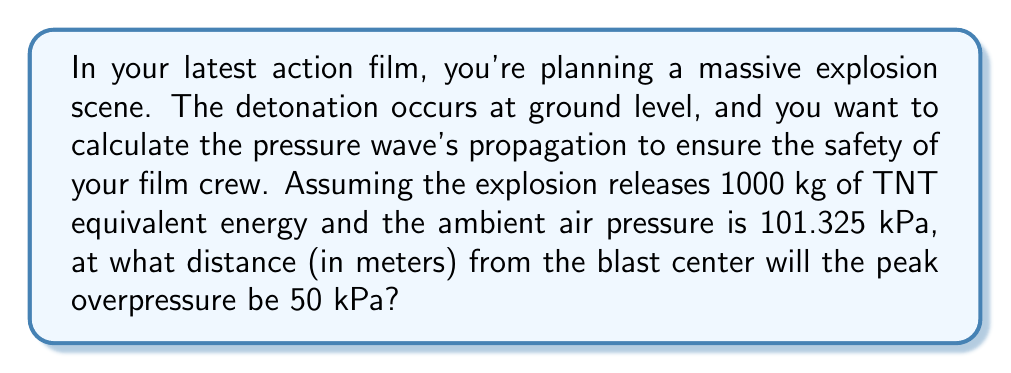Can you answer this question? To solve this problem, we'll use the Sadovsky formula for spherical blast waves. The steps are as follows:

1) The Sadovsky formula for peak overpressure $\Delta P$ (in kPa) is:

   $$\Delta P = \frac{0.084}{Z} + \frac{0.27}{Z^2} + \frac{0.7}{Z^3}$$

   where $Z$ is the scaled distance.

2) We're given that $\Delta P = 50$ kPa. We need to solve for $Z$.

3) The equation can't be solved algebraically, so we'll use numerical methods. Using a calculator or computer, we find that $Z \approx 2.39$.

4) The scaled distance $Z$ is related to the actual distance $R$ (in meters) and the TNT equivalent mass $W$ (in kg) by:

   $$Z = \frac{R}{W^{1/3}}$$

5) Rearranging this equation:

   $$R = Z \cdot W^{1/3}$$

6) We're given that $W = 1000$ kg. Substituting our values:

   $$R = 2.39 \cdot 1000^{1/3} \approx 25.8$$

Therefore, the peak overpressure of 50 kPa will occur at approximately 25.8 meters from the blast center.
Answer: 25.8 meters 